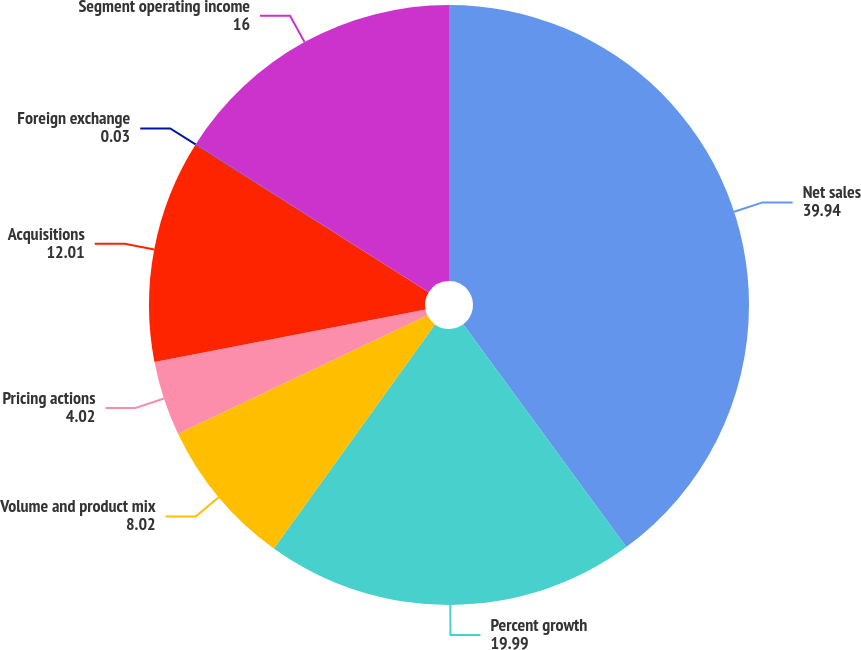<chart> <loc_0><loc_0><loc_500><loc_500><pie_chart><fcel>Net sales<fcel>Percent growth<fcel>Volume and product mix<fcel>Pricing actions<fcel>Acquisitions<fcel>Foreign exchange<fcel>Segment operating income<nl><fcel>39.94%<fcel>19.99%<fcel>8.02%<fcel>4.02%<fcel>12.01%<fcel>0.03%<fcel>16.0%<nl></chart> 